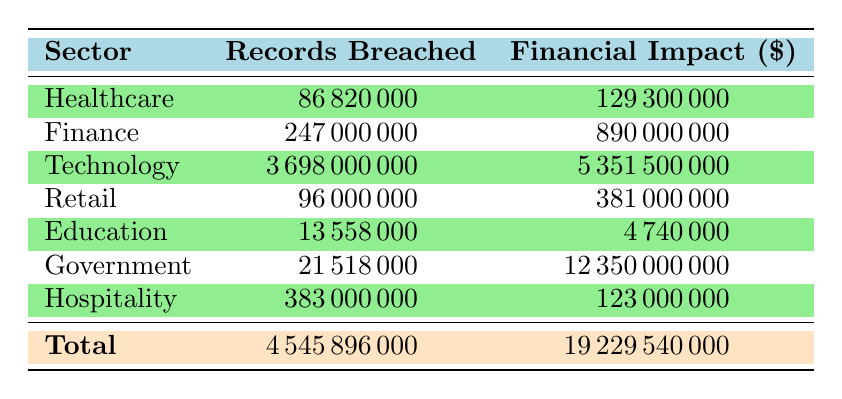What is the total number of records breached across all sectors? To find the total number of records breached, we need to sum all values in the "Records Breached" column: 86820000 (Healthcare) + 247000000 (Finance) + 3698000000 (Technology) + 96000000 (Retail) + 13558000 (Education) + 21518000 (Government) + 383000000 (Hospitality) = 4545896000
Answer: 4545896000 Which sector incurred the highest financial impact due to breaches? By looking at the "Financial Impact" column, we see the highest value is 12350000000 for the Government sector. This is greater than all other sectors listed, such as Technology at 5351500000.
Answer: Government How many records were breached in the Finance sector? The Finance sector has a total of 247000000 records breached as indicated directly in the "Records Breached" column next to the Finance row.
Answer: 247000000 Was the financial impact for the Healthcare sector higher than for the Education sector? The financial impact for the Healthcare sector is 129300000, while for the Education sector it is 4740000. Since 129300000 is significantly greater than 4740000, the statement is true.
Answer: Yes What is the average number of records breached across all sectors? To find the average, we total the records breached (4545896000) and divide by the number of sectors (7): 4545896000 / 7 = 649413714.2857. Rounding this gives approximately 649413714.
Answer: 649413714 How much was the total financial impact from breaches in the Retail sector? From the table, the financial impact for the Retail sector is listed as 381000000. This figure represents the complete financial impact from all incidents within the sector.
Answer: 381000000 Is it true that the Technology sector has the highest number of records breached? Checking the "Records Breached" column, the Technology sector has 3698000000, which is the largest entry compared to others like Healthcare (86820000) or Finance (247000000). Therefore, this statement is true.
Answer: Yes What is the difference in records breached between the Technology sector and the Healthcare sector? The records breached in Technology are 3698000000, and in Healthcare, it is 86820000. The difference is: 3698000000 - 86820000 = 3601180000.
Answer: 3601180000 